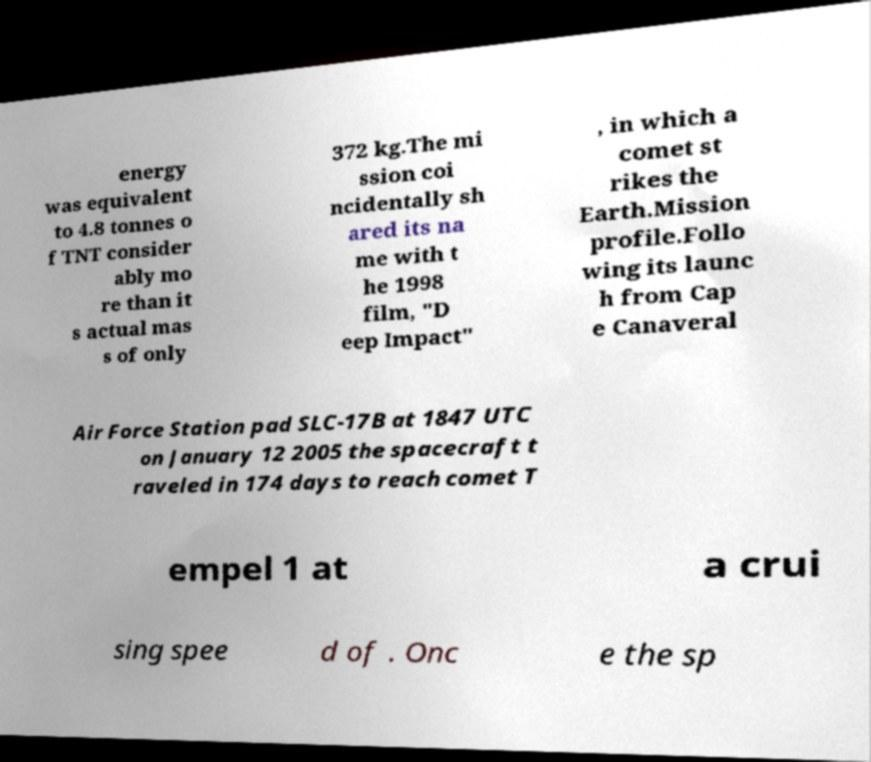What messages or text are displayed in this image? I need them in a readable, typed format. energy was equivalent to 4.8 tonnes o f TNT consider ably mo re than it s actual mas s of only 372 kg.The mi ssion coi ncidentally sh ared its na me with t he 1998 film, "D eep Impact" , in which a comet st rikes the Earth.Mission profile.Follo wing its launc h from Cap e Canaveral Air Force Station pad SLC-17B at 1847 UTC on January 12 2005 the spacecraft t raveled in 174 days to reach comet T empel 1 at a crui sing spee d of . Onc e the sp 